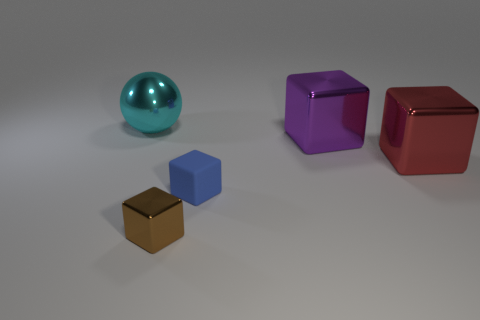Is there any other thing that is the same material as the blue cube?
Make the answer very short. No. Does the metallic block on the left side of the matte cube have the same size as the rubber cube that is in front of the large purple thing?
Keep it short and to the point. Yes. What number of objects are blocks to the left of the purple metal object or brown objects?
Give a very brief answer. 2. Are there fewer large cyan objects than objects?
Your response must be concise. Yes. The small object that is right of the metallic cube left of the small cube that is behind the tiny brown cube is what shape?
Offer a terse response. Cube. Is there a large purple ball?
Make the answer very short. No. Do the cyan metal thing and the shiny block on the left side of the blue block have the same size?
Your answer should be very brief. No. There is a metal thing that is in front of the blue object; are there any purple things behind it?
Your answer should be compact. Yes. There is a object that is on the left side of the big purple thing and behind the matte object; what is its material?
Your answer should be very brief. Metal. What color is the big metal object left of the metal block that is in front of the matte object behind the brown shiny block?
Offer a very short reply. Cyan. 